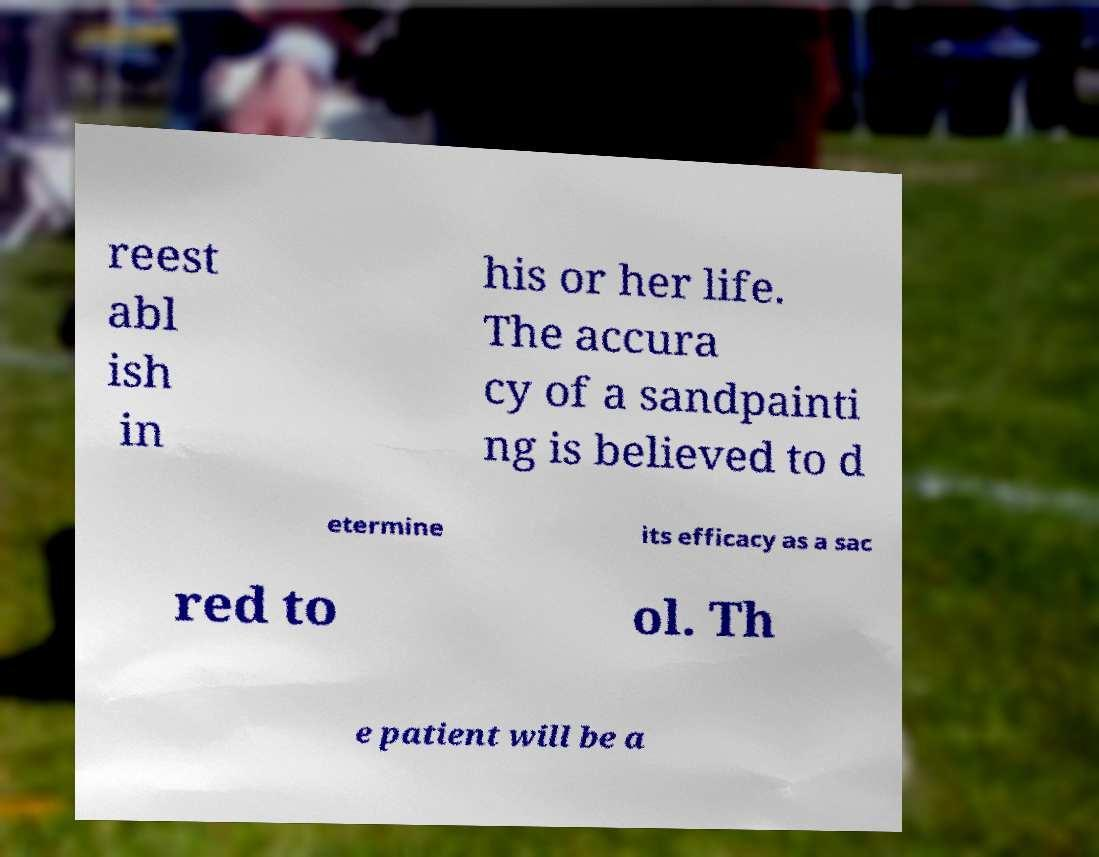Can you accurately transcribe the text from the provided image for me? reest abl ish in his or her life. The accura cy of a sandpainti ng is believed to d etermine its efficacy as a sac red to ol. Th e patient will be a 